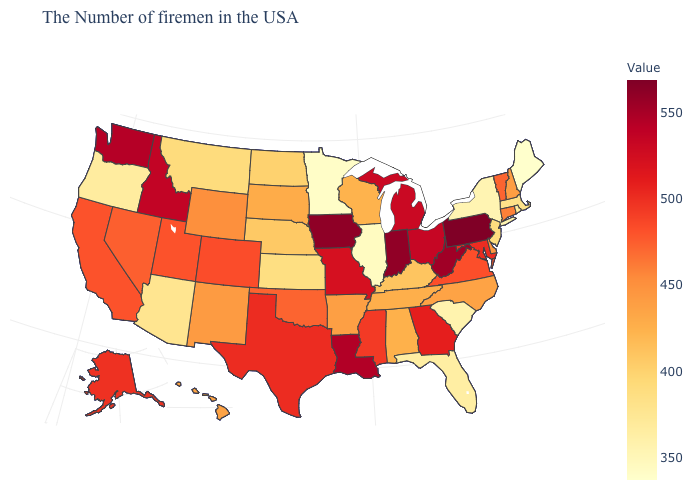Does Kentucky have a higher value than New York?
Give a very brief answer. Yes. Which states hav the highest value in the MidWest?
Quick response, please. Iowa. Does the map have missing data?
Answer briefly. No. 